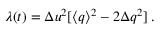Convert formula to latex. <formula><loc_0><loc_0><loc_500><loc_500>\lambda ( t ) = { \Delta u } ^ { 2 } [ \langle q \rangle ^ { 2 } - 2 { \Delta q } ^ { 2 } ] \, .</formula> 